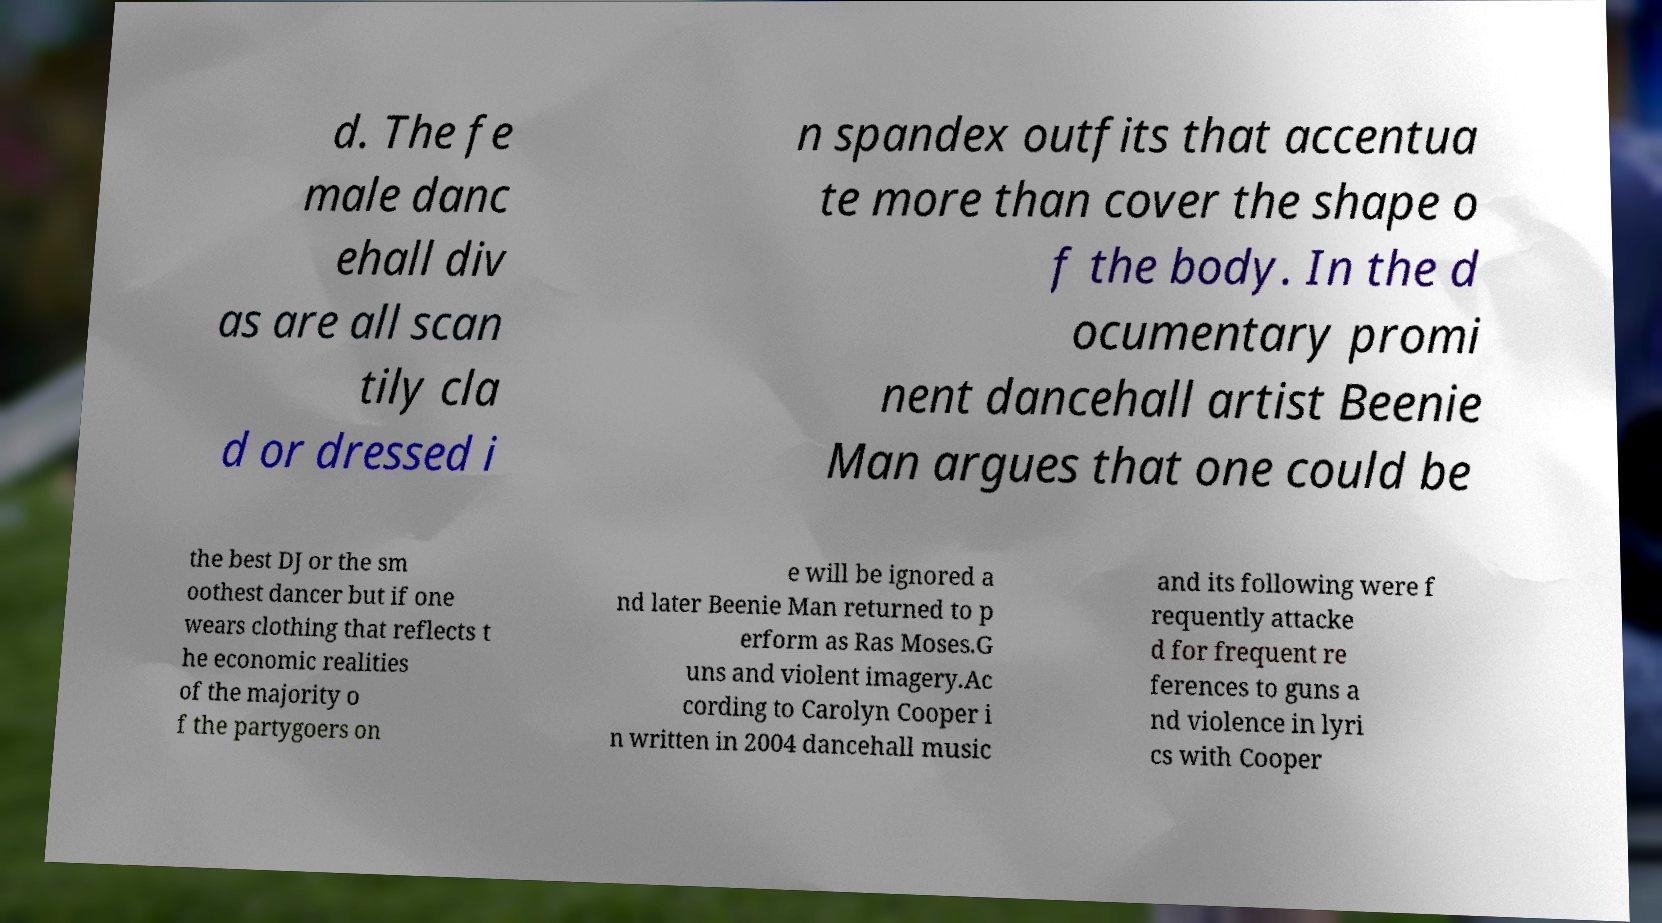Could you assist in decoding the text presented in this image and type it out clearly? d. The fe male danc ehall div as are all scan tily cla d or dressed i n spandex outfits that accentua te more than cover the shape o f the body. In the d ocumentary promi nent dancehall artist Beenie Man argues that one could be the best DJ or the sm oothest dancer but if one wears clothing that reflects t he economic realities of the majority o f the partygoers on e will be ignored a nd later Beenie Man returned to p erform as Ras Moses.G uns and violent imagery.Ac cording to Carolyn Cooper i n written in 2004 dancehall music and its following were f requently attacke d for frequent re ferences to guns a nd violence in lyri cs with Cooper 